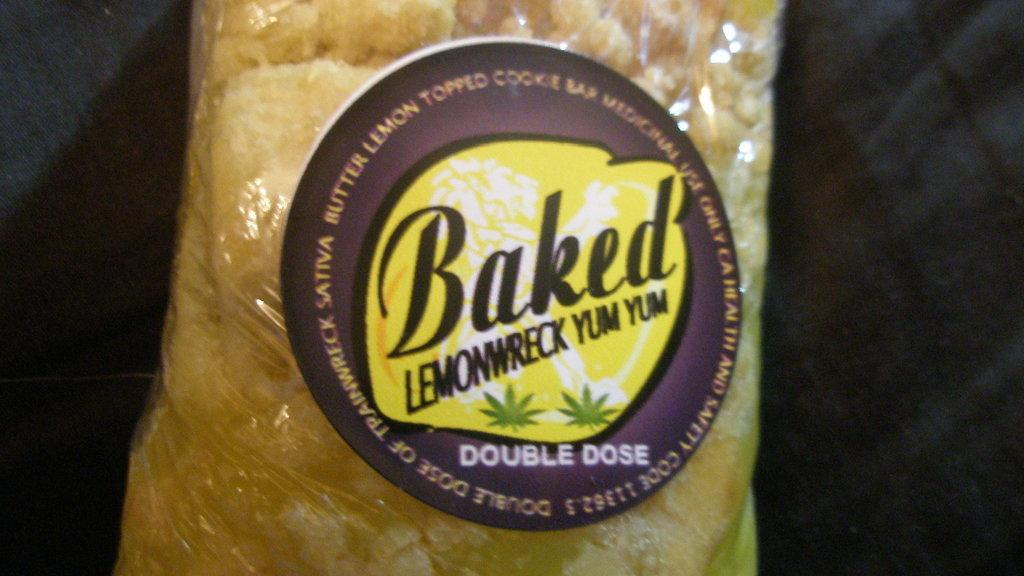What is the main object in the image? There is a food packet in the image. What can be seen on the food packet? The food packet has a logo and text on it. How many spiders are crawling on the food packet in the image? There are no spiders present in the image; it only features a food packet with a logo and text. 